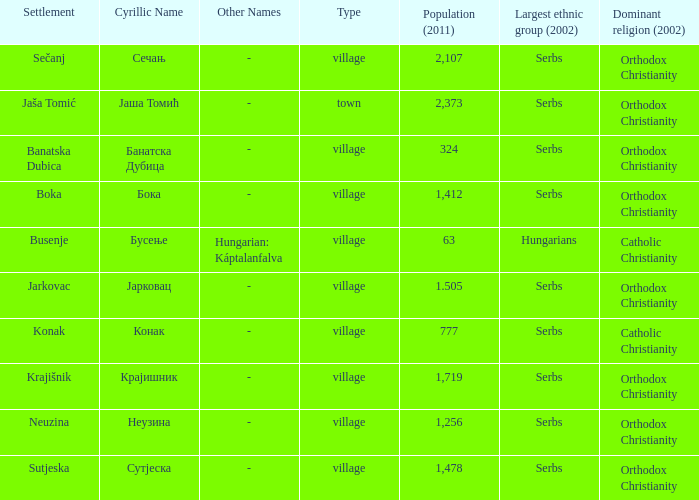What is the ethnic group is конак? Serbs. 